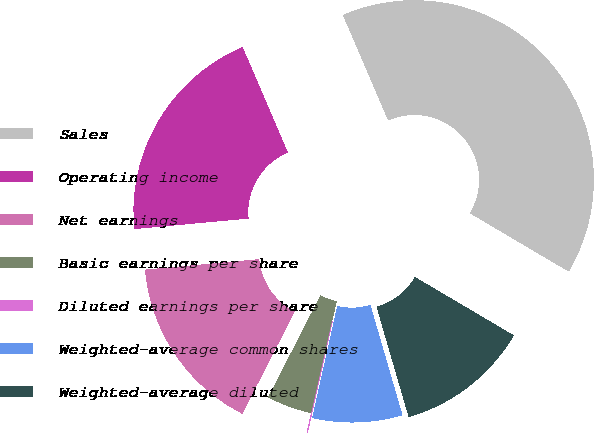Convert chart to OTSL. <chart><loc_0><loc_0><loc_500><loc_500><pie_chart><fcel>Sales<fcel>Operating income<fcel>Net earnings<fcel>Basic earnings per share<fcel>Diluted earnings per share<fcel>Weighted-average common shares<fcel>Weighted-average diluted<nl><fcel>39.95%<fcel>19.99%<fcel>16.0%<fcel>4.02%<fcel>0.03%<fcel>8.01%<fcel>12.0%<nl></chart> 